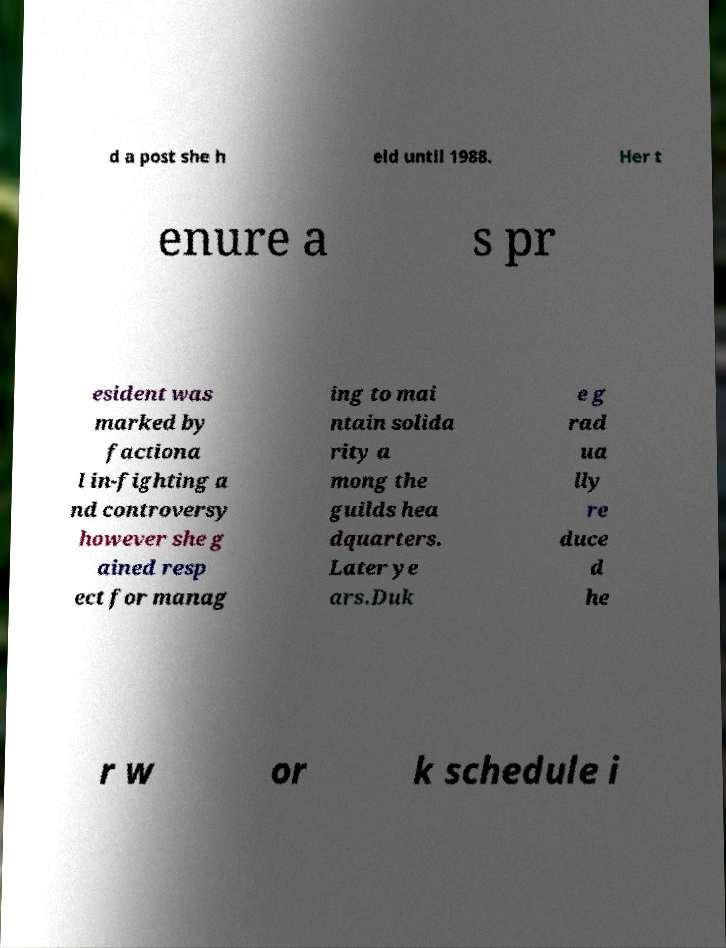There's text embedded in this image that I need extracted. Can you transcribe it verbatim? d a post she h eld until 1988. Her t enure a s pr esident was marked by factiona l in-fighting a nd controversy however she g ained resp ect for manag ing to mai ntain solida rity a mong the guilds hea dquarters. Later ye ars.Duk e g rad ua lly re duce d he r w or k schedule i 